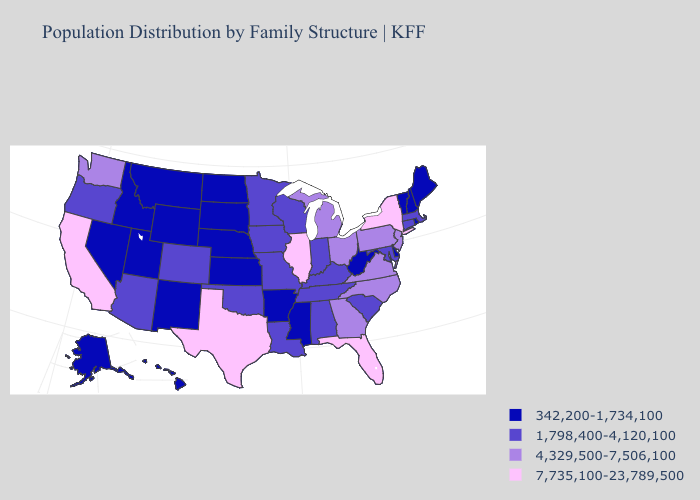Name the states that have a value in the range 342,200-1,734,100?
Be succinct. Alaska, Arkansas, Delaware, Hawaii, Idaho, Kansas, Maine, Mississippi, Montana, Nebraska, Nevada, New Hampshire, New Mexico, North Dakota, Rhode Island, South Dakota, Utah, Vermont, West Virginia, Wyoming. Name the states that have a value in the range 4,329,500-7,506,100?
Concise answer only. Georgia, Michigan, New Jersey, North Carolina, Ohio, Pennsylvania, Virginia, Washington. Name the states that have a value in the range 4,329,500-7,506,100?
Be succinct. Georgia, Michigan, New Jersey, North Carolina, Ohio, Pennsylvania, Virginia, Washington. Among the states that border Mississippi , which have the highest value?
Short answer required. Alabama, Louisiana, Tennessee. How many symbols are there in the legend?
Keep it brief. 4. Does the first symbol in the legend represent the smallest category?
Quick response, please. Yes. Name the states that have a value in the range 7,735,100-23,789,500?
Be succinct. California, Florida, Illinois, New York, Texas. Does the map have missing data?
Give a very brief answer. No. Among the states that border California , which have the highest value?
Quick response, please. Arizona, Oregon. Which states have the lowest value in the USA?
Quick response, please. Alaska, Arkansas, Delaware, Hawaii, Idaho, Kansas, Maine, Mississippi, Montana, Nebraska, Nevada, New Hampshire, New Mexico, North Dakota, Rhode Island, South Dakota, Utah, Vermont, West Virginia, Wyoming. What is the value of North Dakota?
Give a very brief answer. 342,200-1,734,100. Which states have the highest value in the USA?
Keep it brief. California, Florida, Illinois, New York, Texas. Does New York have the highest value in the USA?
Give a very brief answer. Yes. What is the highest value in states that border North Dakota?
Short answer required. 1,798,400-4,120,100. Name the states that have a value in the range 342,200-1,734,100?
Short answer required. Alaska, Arkansas, Delaware, Hawaii, Idaho, Kansas, Maine, Mississippi, Montana, Nebraska, Nevada, New Hampshire, New Mexico, North Dakota, Rhode Island, South Dakota, Utah, Vermont, West Virginia, Wyoming. 